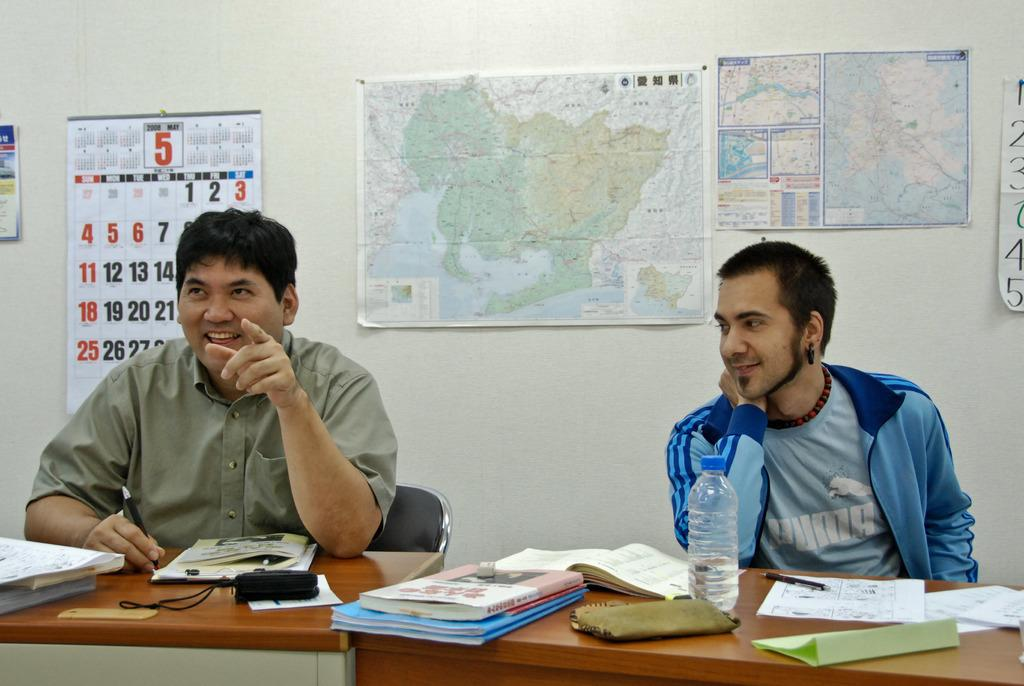What is the color of the wall in the image? The wall in the image is white. What items can be seen on the wall? A calendar is visible on the wall in the image. How many persons are sitting in the image? There are two persons sitting on chairs in the image. What is in front of the chairs? There is: There is a table in front of the chairs. What objects are on the table? There are books on the table in the image. Can you tell me how many brothers are sitting with the persons in the image? There is no mention of a brother in the image; only two persons are sitting on chairs. What type of underwear can be seen on the persons in the image? There is no underwear visible in the image; the persons are fully clothed. 